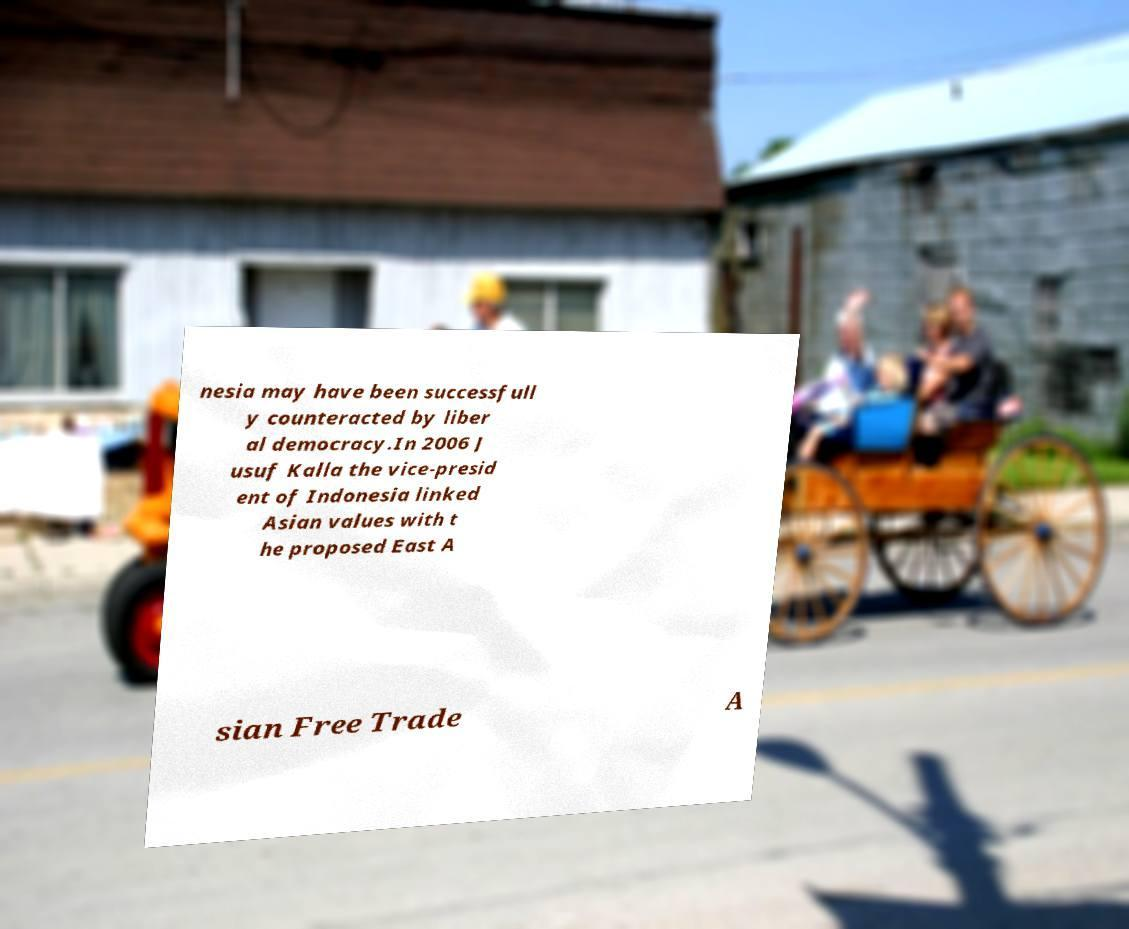Could you assist in decoding the text presented in this image and type it out clearly? nesia may have been successfull y counteracted by liber al democracy.In 2006 J usuf Kalla the vice-presid ent of Indonesia linked Asian values with t he proposed East A sian Free Trade A 